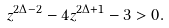Convert formula to latex. <formula><loc_0><loc_0><loc_500><loc_500>z ^ { 2 \Delta - 2 } - 4 z ^ { 2 \Delta + 1 } - 3 > 0 .</formula> 